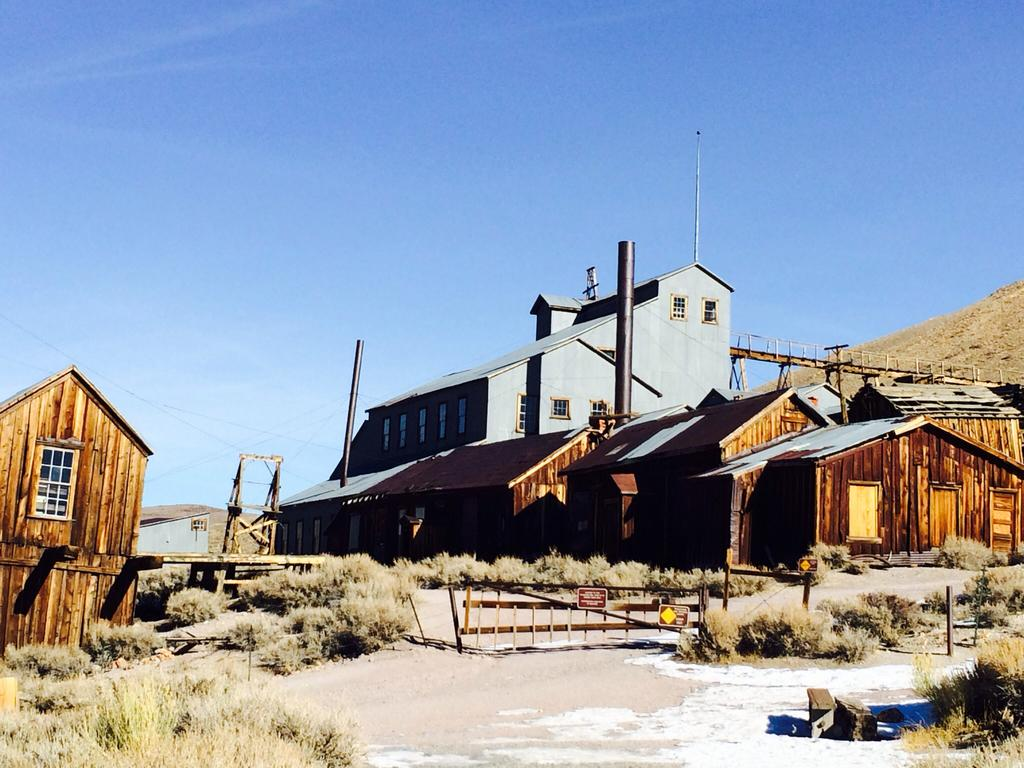What type of houses are visible in the image? There are wooden houses in the image. What is located behind the wooden houses? There is a building behind the wooden houses. What color is the sky in the image? The sky is blue in the image. Where is the key to the bath located in the image? There is no key or bath present in the image; it only features wooden houses, a building, and a blue sky. 